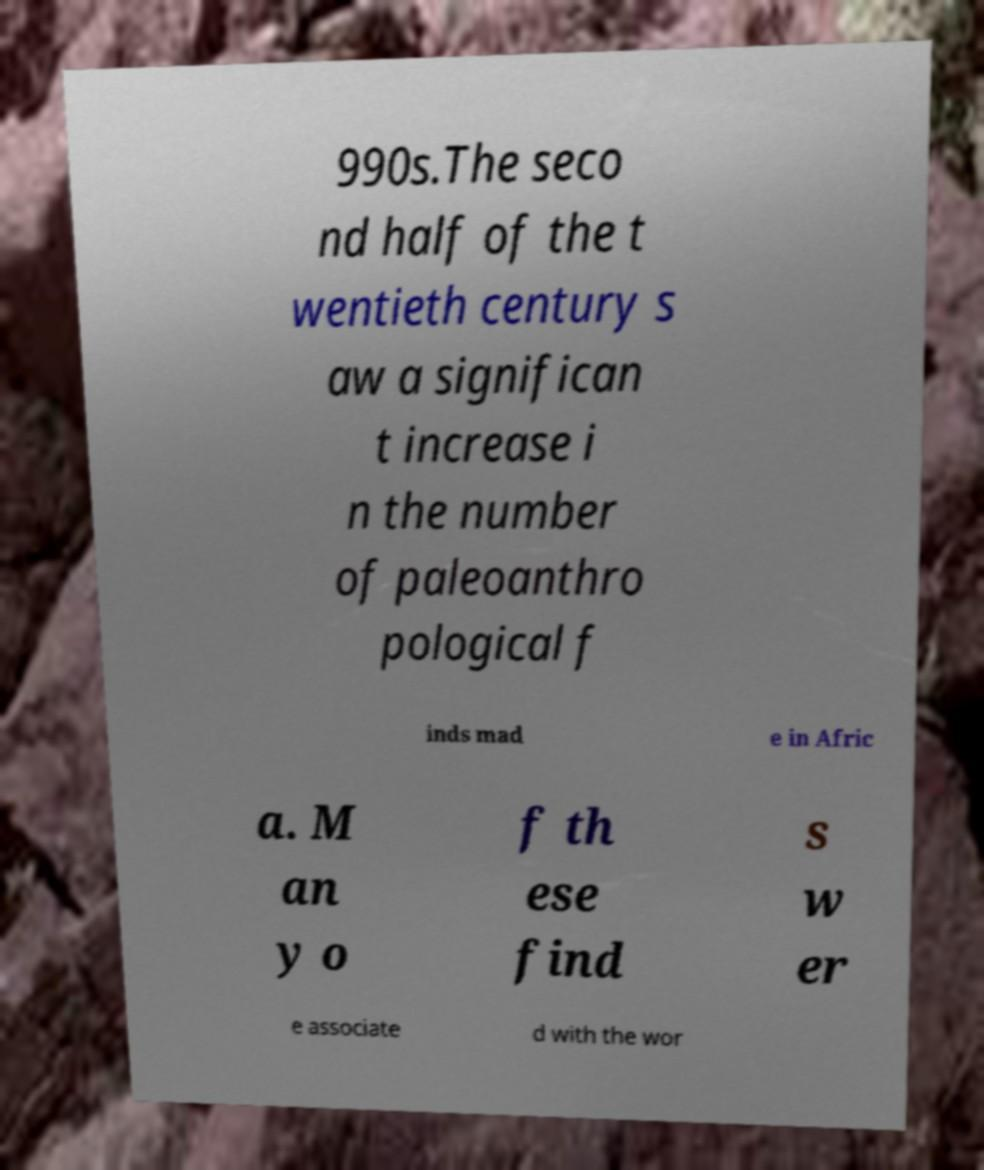Please identify and transcribe the text found in this image. 990s.The seco nd half of the t wentieth century s aw a significan t increase i n the number of paleoanthro pological f inds mad e in Afric a. M an y o f th ese find s w er e associate d with the wor 